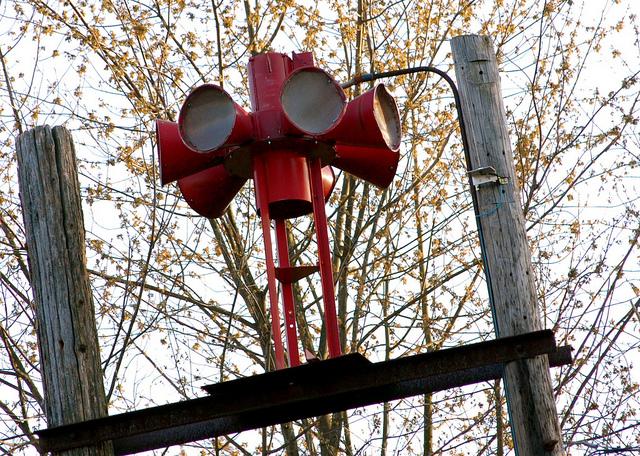How many vertical posts are present?
Keep it brief. 2. What is in the picture?
Quick response, please. Siren. How many loudspeakers can be seen?
Be succinct. 7. 